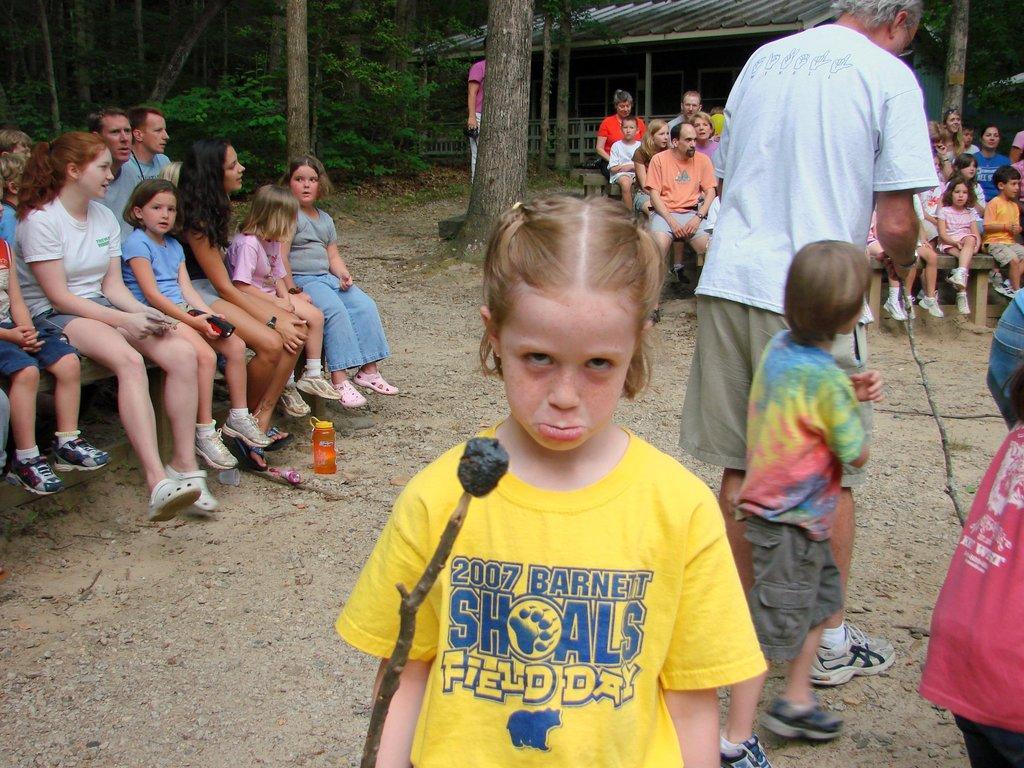How would you summarize this image in a sentence or two? This picture is clicked outside. In the foreground there is a girl wearing yellow color t-shirt, holding a stick and standing on the ground. On the right we can see a person and some kids seems to be standing on the ground. In the background we can see the group of people sitting on the benches and we can see the tent, plants, trunks of the trees and some other objects. 